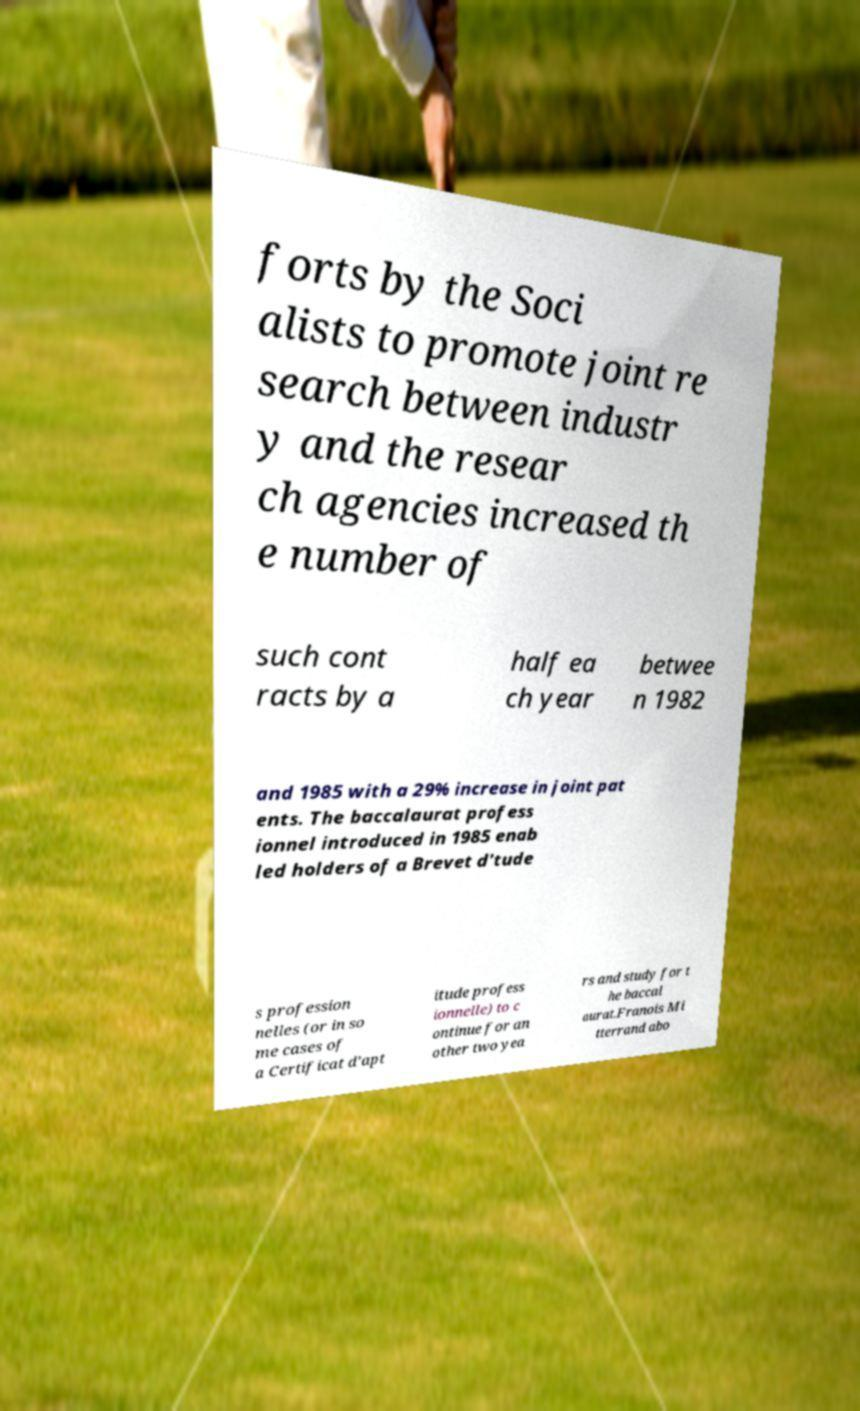Could you assist in decoding the text presented in this image and type it out clearly? forts by the Soci alists to promote joint re search between industr y and the resear ch agencies increased th e number of such cont racts by a half ea ch year betwee n 1982 and 1985 with a 29% increase in joint pat ents. The baccalaurat profess ionnel introduced in 1985 enab led holders of a Brevet d'tude s profession nelles (or in so me cases of a Certificat d’apt itude profess ionnelle) to c ontinue for an other two yea rs and study for t he baccal aurat.Franois Mi tterrand abo 